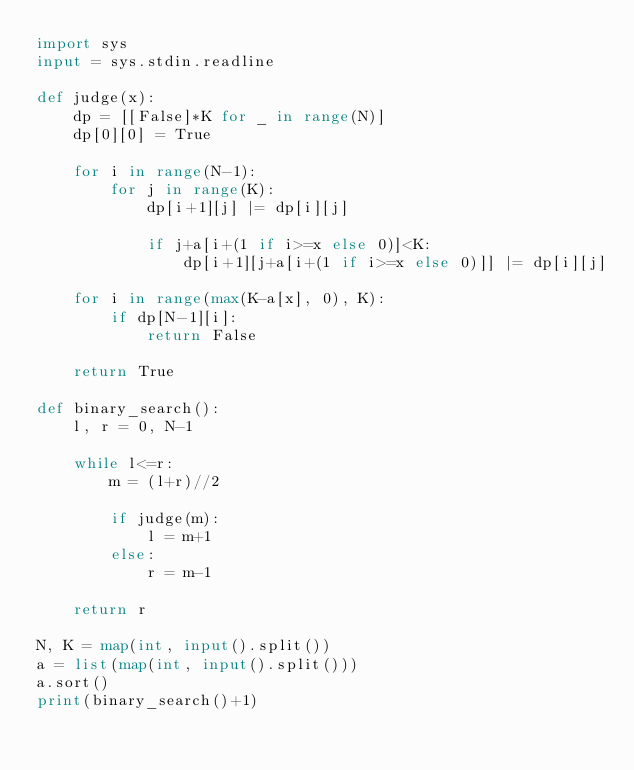<code> <loc_0><loc_0><loc_500><loc_500><_Python_>import sys
input = sys.stdin.readline

def judge(x):
    dp = [[False]*K for _ in range(N)]
    dp[0][0] = True
    
    for i in range(N-1):
        for j in range(K):
            dp[i+1][j] |= dp[i][j]
            
            if j+a[i+(1 if i>=x else 0)]<K:
                dp[i+1][j+a[i+(1 if i>=x else 0)]] |= dp[i][j]
    
    for i in range(max(K-a[x], 0), K):
        if dp[N-1][i]:
            return False
    
    return True
    
def binary_search():
    l, r = 0, N-1
    
    while l<=r:
        m = (l+r)//2
        
        if judge(m):
            l = m+1
        else:
            r = m-1
    
    return r

N, K = map(int, input().split())
a = list(map(int, input().split()))
a.sort()
print(binary_search()+1)</code> 